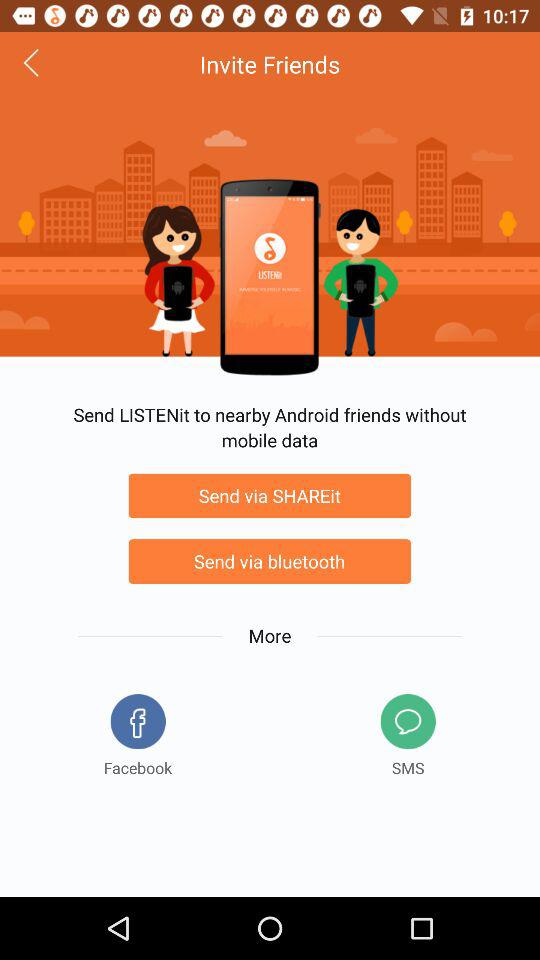Which applications can be used for sending "LISTENit" to nearby Android friends without mobile data? The applications that can be used are "SHAREit" and "bluetooth". 